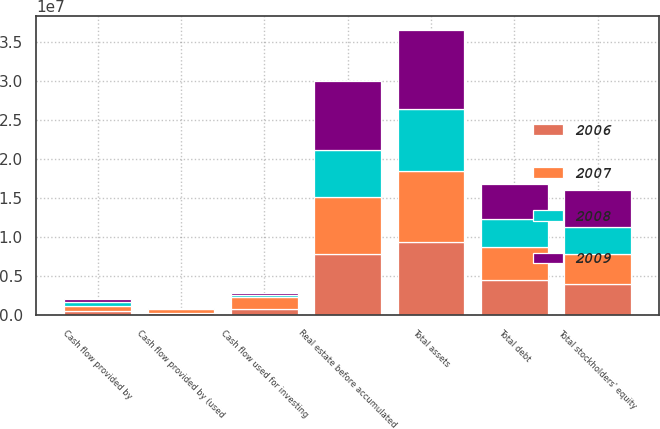<chart> <loc_0><loc_0><loc_500><loc_500><stacked_bar_chart><ecel><fcel>Real estate before accumulated<fcel>Total assets<fcel>Total debt<fcel>Total stockholders' equity<fcel>Cash flow provided by<fcel>Cash flow used for investing<fcel>Cash flow provided by (used<nl><fcel>2009<fcel>8.88234e+06<fcel>1.01622e+07<fcel>4.43438e+06<fcel>4.85297e+06<fcel>403582<fcel>343236<fcel>74465<nl><fcel>2006<fcel>7.81892e+06<fcel>9.39715e+06<fcel>4.55665e+06<fcel>3.9837e+06<fcel>567599<fcel>781350<fcel>262429<nl><fcel>2007<fcel>7.32504e+06<fcel>9.09782e+06<fcel>4.21642e+06<fcel>3.89422e+06<fcel>665989<fcel>1.50761e+06<fcel>584056<nl><fcel>2008<fcel>6.00132e+06<fcel>7.86928e+06<fcel>3.58724e+06<fcel>3.36683e+06<fcel>455569<fcel>246221<fcel>59444<nl></chart> 